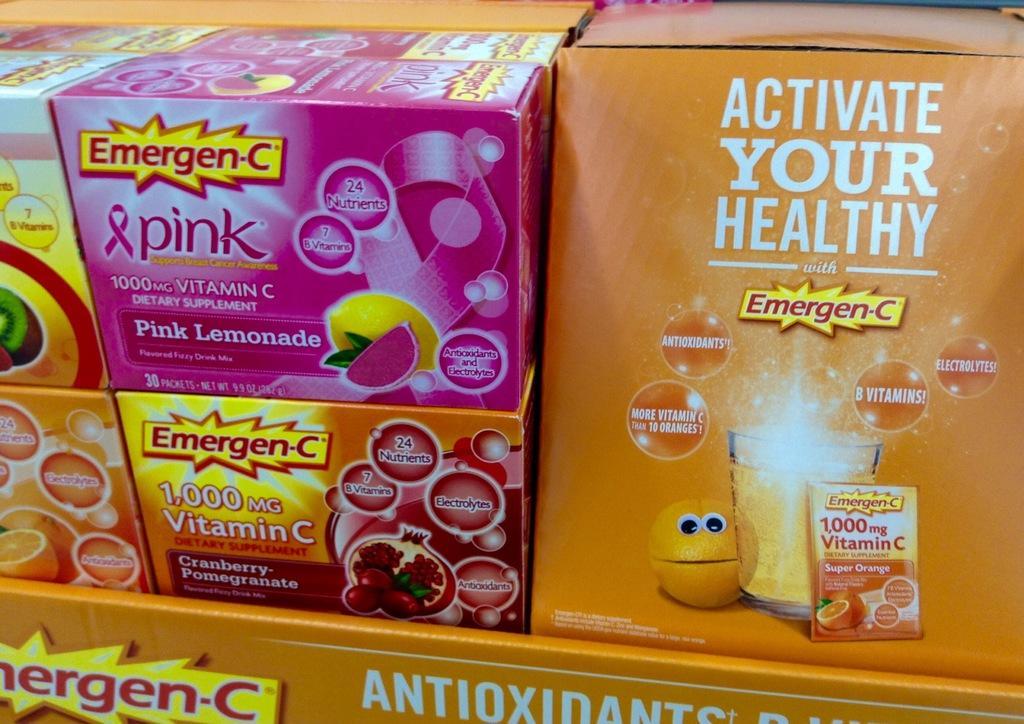Please provide a concise description of this image. In this image we can see food packets on the rack. 